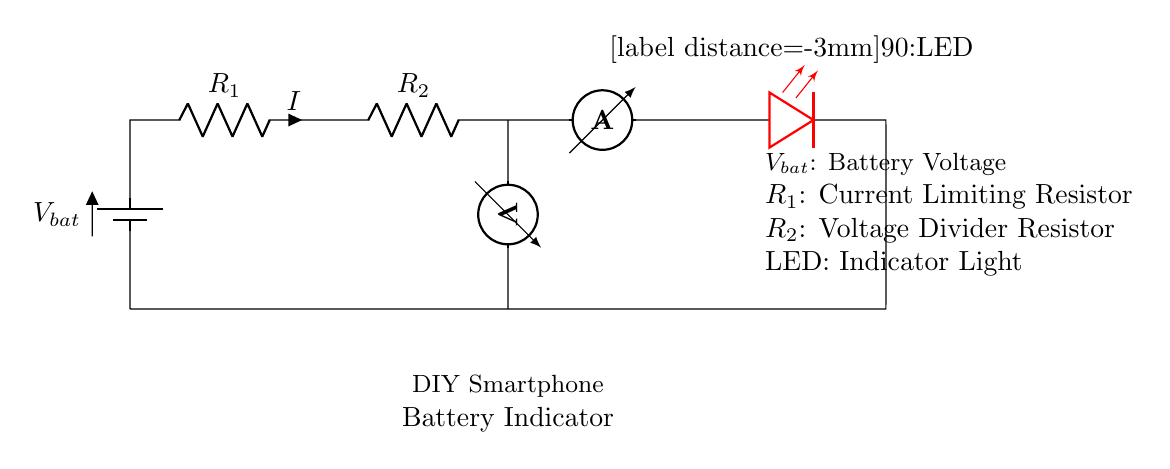What is the component that indicates the battery status? The LED is positioned in the circuit to visually indicate the battery status through illumination.
Answer: LED What is the function of resistor R1? R1 is a current limiting resistor, which controls the amount of current flowing through the circuit to prevent damage to components, especially the LED.
Answer: Current Limiting Resistor How many resistors are present in the circuit? There are two resistors, R1 and R2, each serving different functions within the circuit.
Answer: Two What does the voltmeter measure? The voltmeter is connected across resistor R2, measuring the voltage drop across it to provide information about the battery voltage.
Answer: Voltage across R2 What is the relationship between R2 and the voltage measurement? Since R2 is part of a voltage divider, the voltage measured across it will be proportional to the battery voltage, based on the values of R1 and R2.
Answer: Proportional What happens if the current through the LED exceeds a certain limit? If the current through the LED exceeds its rated limit, it can cause permanent damage, leading to failure or burnout of the LED.
Answer: Burnout What is the primary purpose of the circuit? The primary purpose of the circuit is to indicate the battery voltage level, providing users with a visual representation of the battery's charge status.
Answer: Battery Indicator 